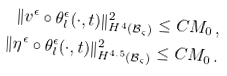<formula> <loc_0><loc_0><loc_500><loc_500>\| v ^ { \epsilon } \circ \theta _ { l } ^ { \epsilon } ( \cdot , t ) \| ^ { 2 } _ { H ^ { 4 } ( \mathcal { B } _ { \varsigma } ) } \leq C M _ { 0 } \, , \\ \| \eta ^ { \epsilon } \circ \theta _ { l } ^ { \epsilon } ( \cdot , t ) \| ^ { 2 } _ { H ^ { 4 . 5 } ( \mathcal { B } _ { \varsigma } ) } \leq C M _ { 0 } \, .</formula> 